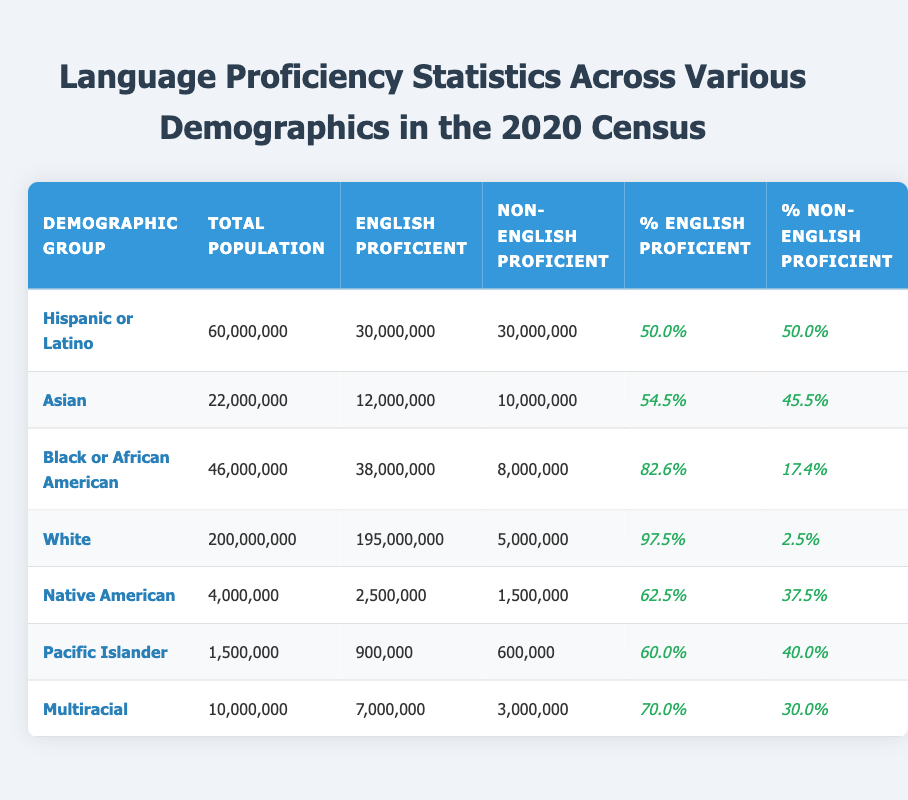What is the total population of the Asian demographic group? The total population for the Asian demographic group is listed directly in the table as 22,000,000.
Answer: 22,000,000 How many people in the Black or African American demographic group are non-English proficient? In the table, the number of non-English proficient individuals in the Black or African American group is given as 8,000,000.
Answer: 8,000,000 What percentage of the Native American demographic group is English proficient? According to the table, the percentage of English proficient individuals in the Native American group is stated as 62.5%.
Answer: 62.5% Which demographic group has the highest percentage of English proficiency? By comparing the percentages in the table, the White demographic group has the highest percentage of English proficiency at 97.5%.
Answer: White If we sum the total populations of all demographic groups shown, what is the total? The total population can be calculated by adding all individual populations: 60,000,000 + 22,000,000 + 46,000,000 + 200,000,000 + 4,000,000 + 1,500,000 + 10,000,000 = 343,500,000.
Answer: 343,500,000 Is the total number of English proficient individuals across all demographic groups greater than 300 million? To determine this, we sum the English proficient individuals for each group: 30,000,000 + 12,000,000 + 38,000,000 + 195,000,000 + 2,500,000 + 900,000 + 7,000,000 = 285,400,000, which is less than 300 million.
Answer: No What is the difference in the number of English proficient individuals between the Hispanic or Latino and Asian demographic groups? To find the difference, we subtract the number of English proficient individuals in the Hispanic or Latino group (30,000,000) from that in the Asian group (12,000,000): 30,000,000 - 12,000,000 = 18,000,000.
Answer: 18,000,000 For which demographic group is the proportion of non-English proficient individuals the highest? By examining the non-English proficient percentages from the table, the Hispanic or Latino demographic group shows a percentage of 50% which is the highest among all groups.
Answer: Hispanic or Latino What is the average percentage of English proficiency among the demographic groups? To calculate the average, sum the percentages of English proficient individuals (50.0% + 54.5% + 82.6% + 97.5% + 62.5% + 60.0% + 70.0% = 377.1%) and divide by the number of groups (7): 377.1% / 7 = 53.87%.
Answer: 53.87% True or False: More than half of the Pacific Islander demographic group is English proficient. Referring to the table, the percentage of English proficient individuals in the Pacific Islander group is 60.0%, which is indeed more than half.
Answer: True 